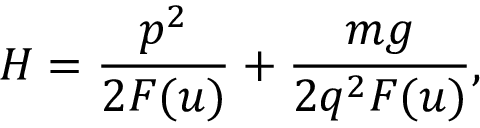Convert formula to latex. <formula><loc_0><loc_0><loc_500><loc_500>H = \frac { p ^ { 2 } } { 2 F ( u ) } + \frac { m g } { 2 q ^ { 2 } F ( u ) } ,</formula> 